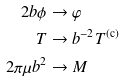Convert formula to latex. <formula><loc_0><loc_0><loc_500><loc_500>2 b \phi & \rightarrow \varphi \\ T & \rightarrow b ^ { - 2 } T ^ { \text {(c)} } \\ 2 \pi \mu b ^ { 2 } & \rightarrow M</formula> 